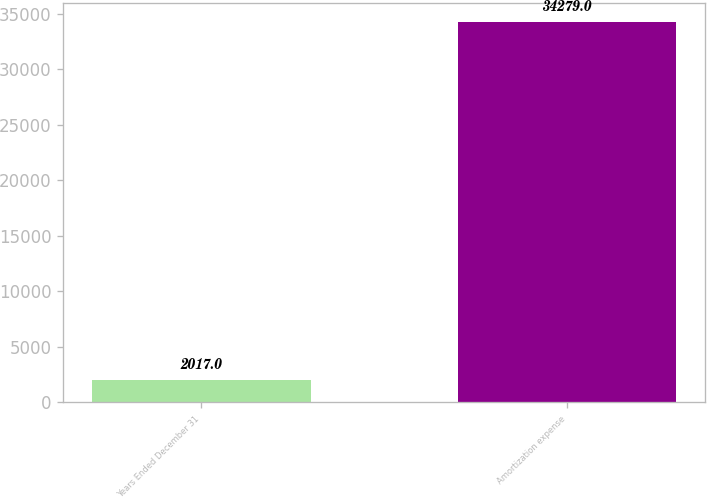Convert chart. <chart><loc_0><loc_0><loc_500><loc_500><bar_chart><fcel>Years Ended December 31<fcel>Amortization expense<nl><fcel>2017<fcel>34279<nl></chart> 